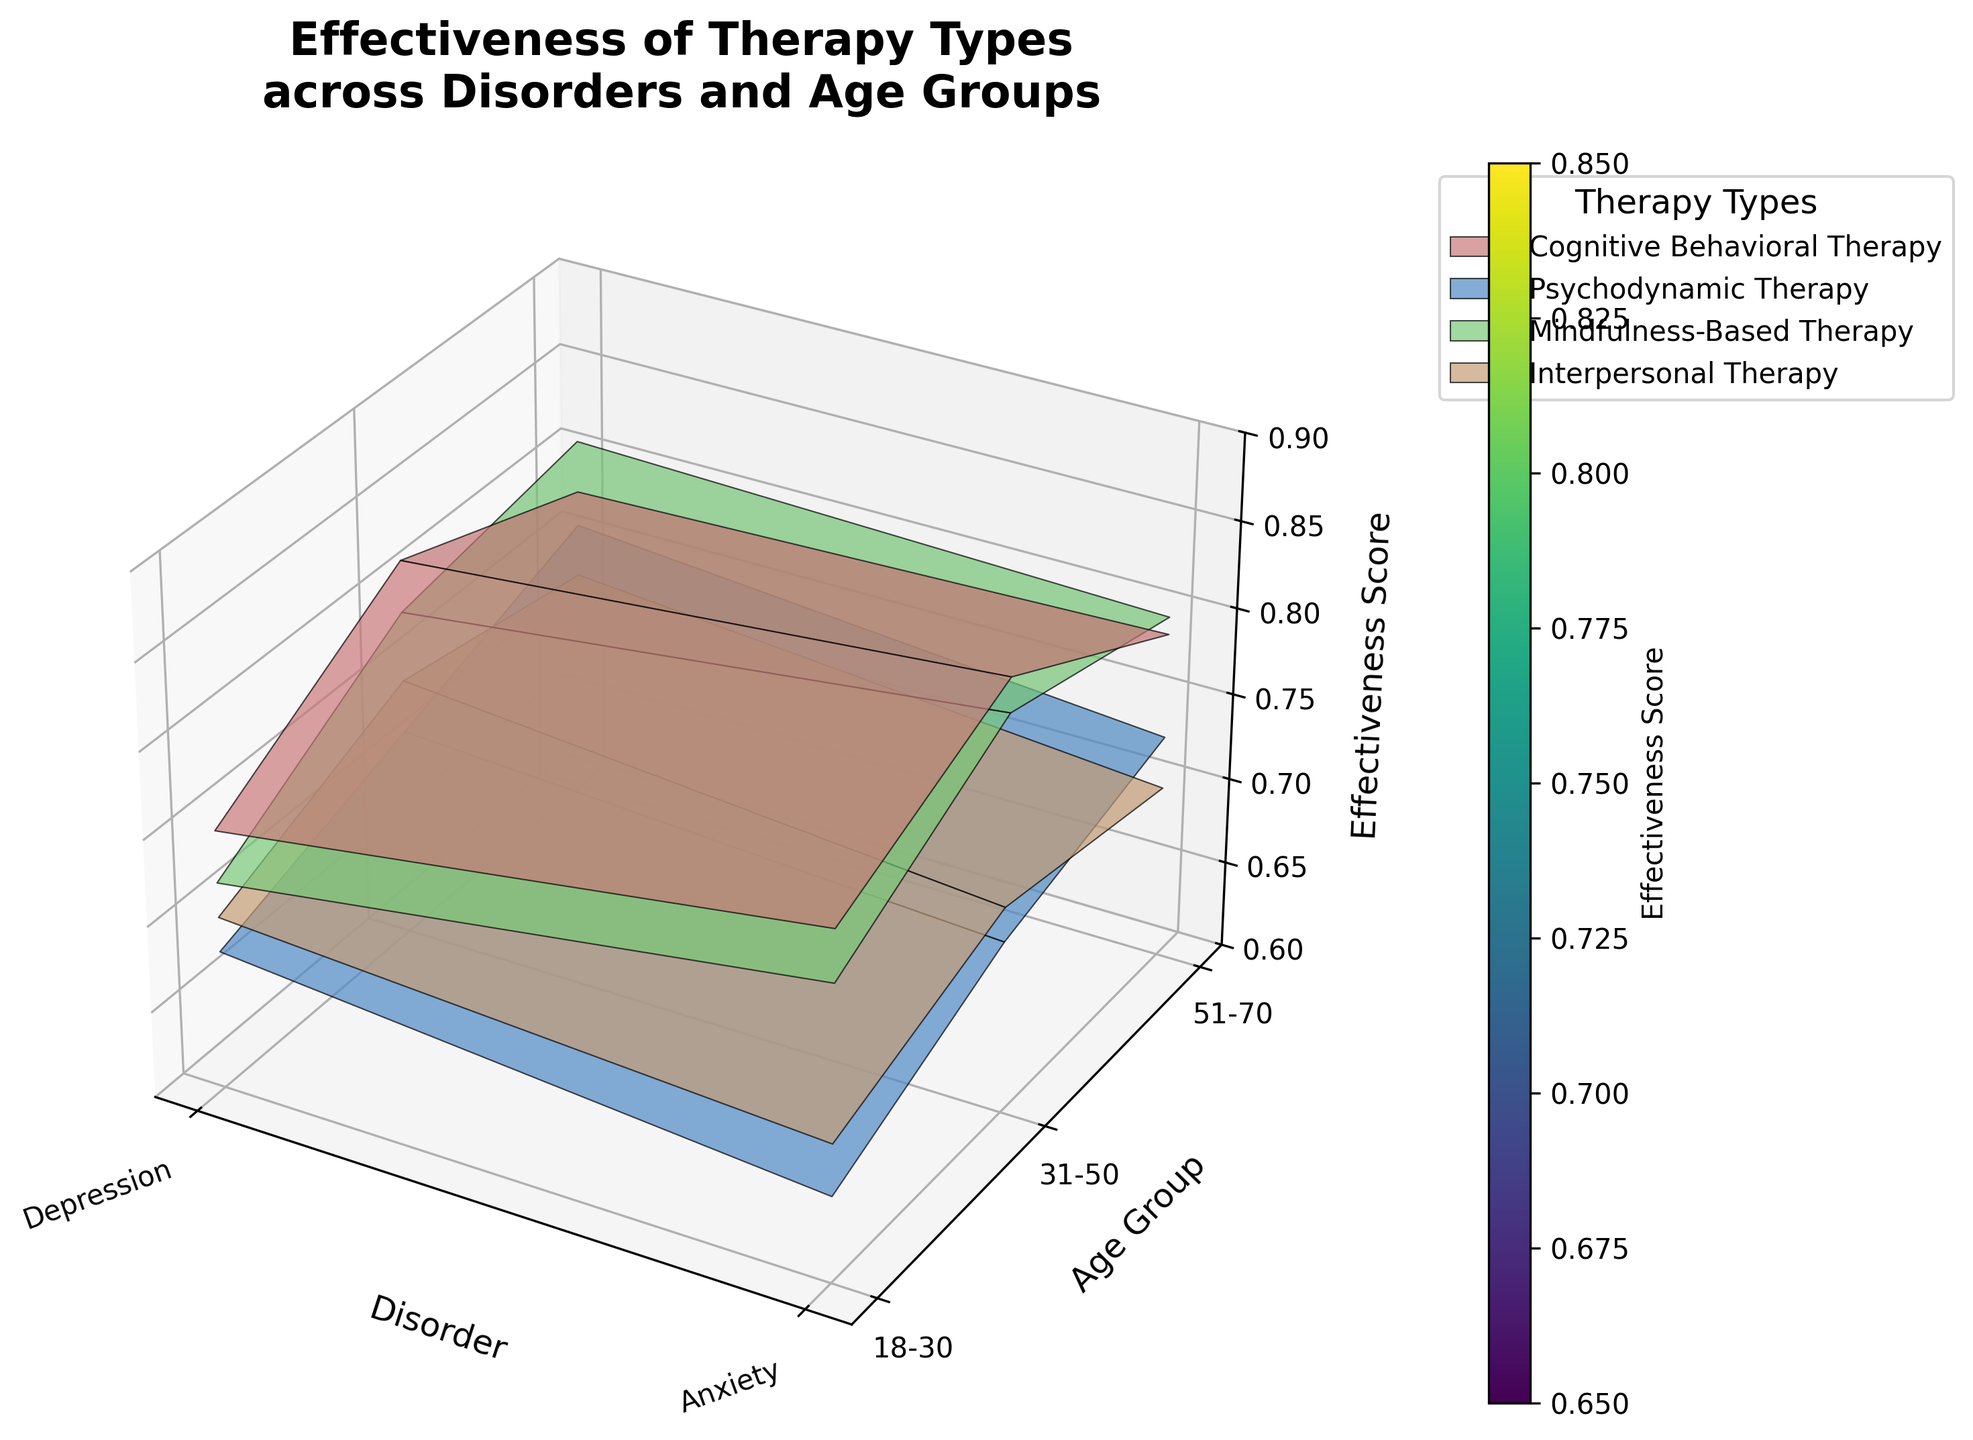How many therapy types are compared in the figure? The legend on the right side of the figure shows labels for the therapy types including Cognitive Behavioral Therapy, Psychodynamic Therapy, Mindfulness-Based Therapy, and Interpersonal Therapy.
Answer: 4 Which disorder has the highest effectiveness score for 31-50 age group using Mindfulness-Based Therapy? The 3D surface plot indicates that the highest effectiveness score for the 31-50 age group using Mindfulness-Based Therapy is seen with Anxiety, which shows an effectiveness score of 0.83.
Answer: Anxiety What is the effectiveness score difference between Cognitive Behavioral Therapy and Psychodynamic Therapy for Depression in patients aged 18-30? By examining the surface plot near Depression (on the x-axis) and 18-30 (on the y-axis), you find that Cognitive Behavioral Therapy has an effectiveness score of 0.75 and Psychodynamic Therapy has 0.68. The difference is 0.75 - 0.68 = 0.07.
Answer: 0.07 Which therapy shows the most consistent effectiveness across all age groups for Anxiety? Looking at Anxiety (on the x-axis) and observing the colors of the surfaces across all age groups, Mindfulness-Based Therapy appears most consistent as it shows slight variation, maintaining scores around 0.77, 0.83, and 0.80.
Answer: Mindfulness-Based Therapy What is the average effectiveness score of Cognitive Behavioral Therapy for Anxiety across all age groups? Checked Anxiety for Cognitive Behavioral Therapy effectiveness scores at all age groups: 18-30 (0.80), 31-50 (0.85), and 51-70 (0.79). The average is (0.80 + 0.85 + 0.79) / 3 = 0.81.
Answer: 0.81 How does the effectiveness of Interpersonal Therapy for Depression compare between the oldest and youngest age groups? Observing Depression (on the x-axis) for Interpersonal Therapy, the effectiveness score for 18-30 is 0.70, while for 51-70 it is 0.73. Therefore, it increases from youngest 0.70 to oldest 0.73.
Answer: It increases Which age group shows the highest effectiveness score for Psychodynamic Therapy in treating Anxiety? Checking Anxiety for Psychodynamic Therapy across all age groups, the effectiveness scores are 0.65 (18-30), 0.70 (31-50), and 0.73 (51-70). The highest score is in the 51-70 age group.
Answer: 51-70 What is the total combined effectiveness score for 18-30 age group across all therapy types for Depression? Add the effectiveness scores of all therapies for Depression in the 18-30 age group: Cognitive Behavioral (0.75) + Psychodynamic (0.68) + Mindfulness-Based (0.72) + Interpersonal (0.70). Therefore, 0.75 + 0.68 + 0.72 + 0.70 = 2.85.
Answer: 2.85 